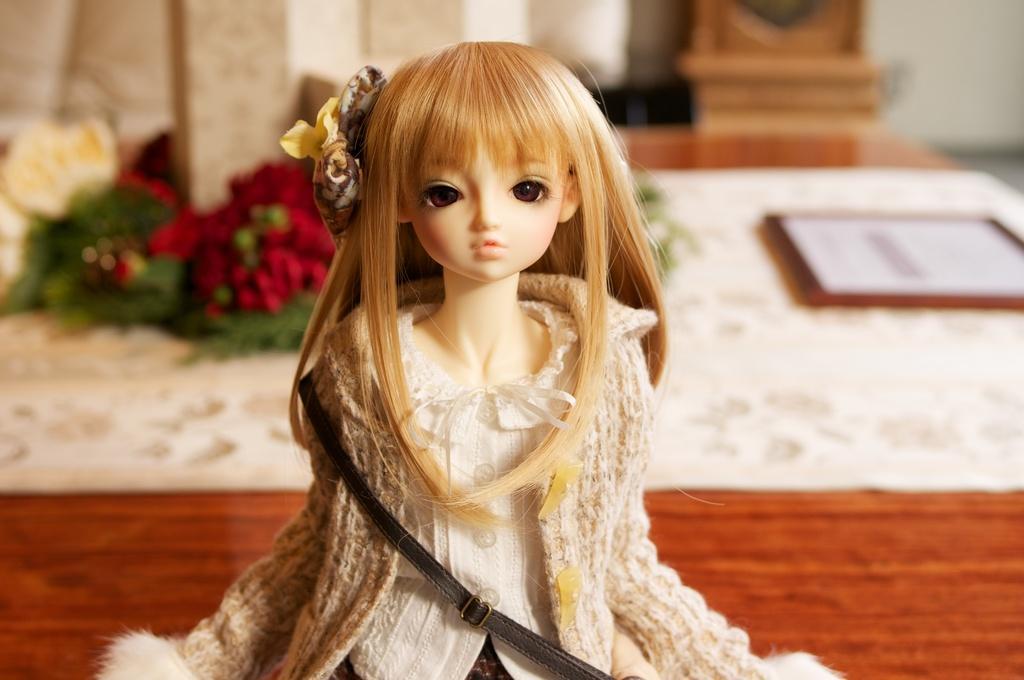How would you summarize this image in a sentence or two? In this image I can see a doll in the front and I can see she is wearing white and cream colour dress. In the background I can see few red colour things, a white colour paper and few green colour things. I can also see this image is little bit blurry in the background. 